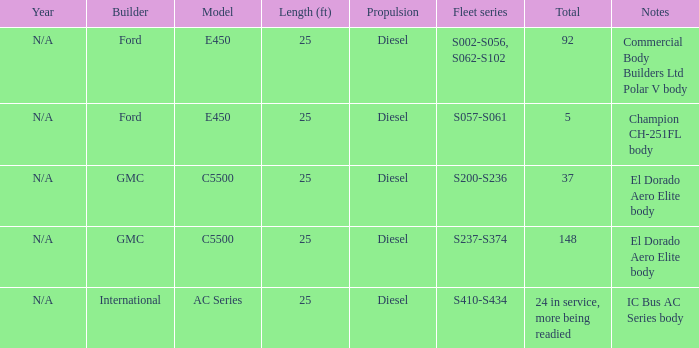How many global constructors are there? 24 in service, more being readied. 